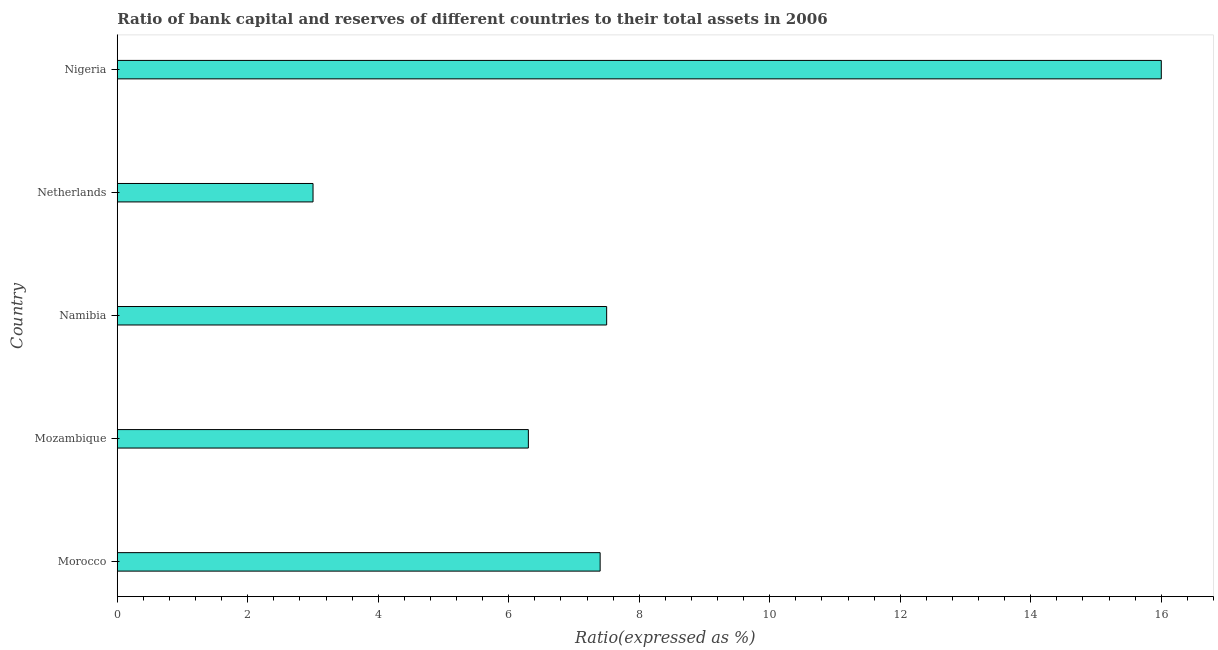Does the graph contain grids?
Give a very brief answer. No. What is the title of the graph?
Your response must be concise. Ratio of bank capital and reserves of different countries to their total assets in 2006. What is the label or title of the X-axis?
Provide a succinct answer. Ratio(expressed as %). In which country was the bank capital to assets ratio maximum?
Provide a short and direct response. Nigeria. What is the sum of the bank capital to assets ratio?
Your response must be concise. 40.2. What is the average bank capital to assets ratio per country?
Keep it short and to the point. 8.04. In how many countries, is the bank capital to assets ratio greater than 12.4 %?
Provide a short and direct response. 1. What is the ratio of the bank capital to assets ratio in Mozambique to that in Nigeria?
Your response must be concise. 0.39. Is the bank capital to assets ratio in Mozambique less than that in Nigeria?
Provide a succinct answer. Yes. What is the difference between the highest and the second highest bank capital to assets ratio?
Provide a succinct answer. 8.5. What is the difference between the highest and the lowest bank capital to assets ratio?
Provide a short and direct response. 13. In how many countries, is the bank capital to assets ratio greater than the average bank capital to assets ratio taken over all countries?
Make the answer very short. 1. How many bars are there?
Keep it short and to the point. 5. What is the difference between two consecutive major ticks on the X-axis?
Offer a terse response. 2. What is the Ratio(expressed as %) of Morocco?
Your response must be concise. 7.4. What is the Ratio(expressed as %) of Mozambique?
Your answer should be very brief. 6.3. What is the Ratio(expressed as %) in Namibia?
Your answer should be compact. 7.5. What is the Ratio(expressed as %) in Netherlands?
Give a very brief answer. 3. What is the difference between the Ratio(expressed as %) in Morocco and Namibia?
Provide a succinct answer. -0.1. What is the difference between the Ratio(expressed as %) in Morocco and Nigeria?
Offer a very short reply. -8.6. What is the difference between the Ratio(expressed as %) in Mozambique and Namibia?
Make the answer very short. -1.2. What is the difference between the Ratio(expressed as %) in Mozambique and Netherlands?
Offer a terse response. 3.3. What is the difference between the Ratio(expressed as %) in Mozambique and Nigeria?
Offer a terse response. -9.7. What is the difference between the Ratio(expressed as %) in Namibia and Nigeria?
Your response must be concise. -8.5. What is the difference between the Ratio(expressed as %) in Netherlands and Nigeria?
Provide a succinct answer. -13. What is the ratio of the Ratio(expressed as %) in Morocco to that in Mozambique?
Your response must be concise. 1.18. What is the ratio of the Ratio(expressed as %) in Morocco to that in Namibia?
Provide a short and direct response. 0.99. What is the ratio of the Ratio(expressed as %) in Morocco to that in Netherlands?
Give a very brief answer. 2.47. What is the ratio of the Ratio(expressed as %) in Morocco to that in Nigeria?
Keep it short and to the point. 0.46. What is the ratio of the Ratio(expressed as %) in Mozambique to that in Namibia?
Make the answer very short. 0.84. What is the ratio of the Ratio(expressed as %) in Mozambique to that in Nigeria?
Your answer should be very brief. 0.39. What is the ratio of the Ratio(expressed as %) in Namibia to that in Netherlands?
Provide a succinct answer. 2.5. What is the ratio of the Ratio(expressed as %) in Namibia to that in Nigeria?
Give a very brief answer. 0.47. What is the ratio of the Ratio(expressed as %) in Netherlands to that in Nigeria?
Provide a succinct answer. 0.19. 